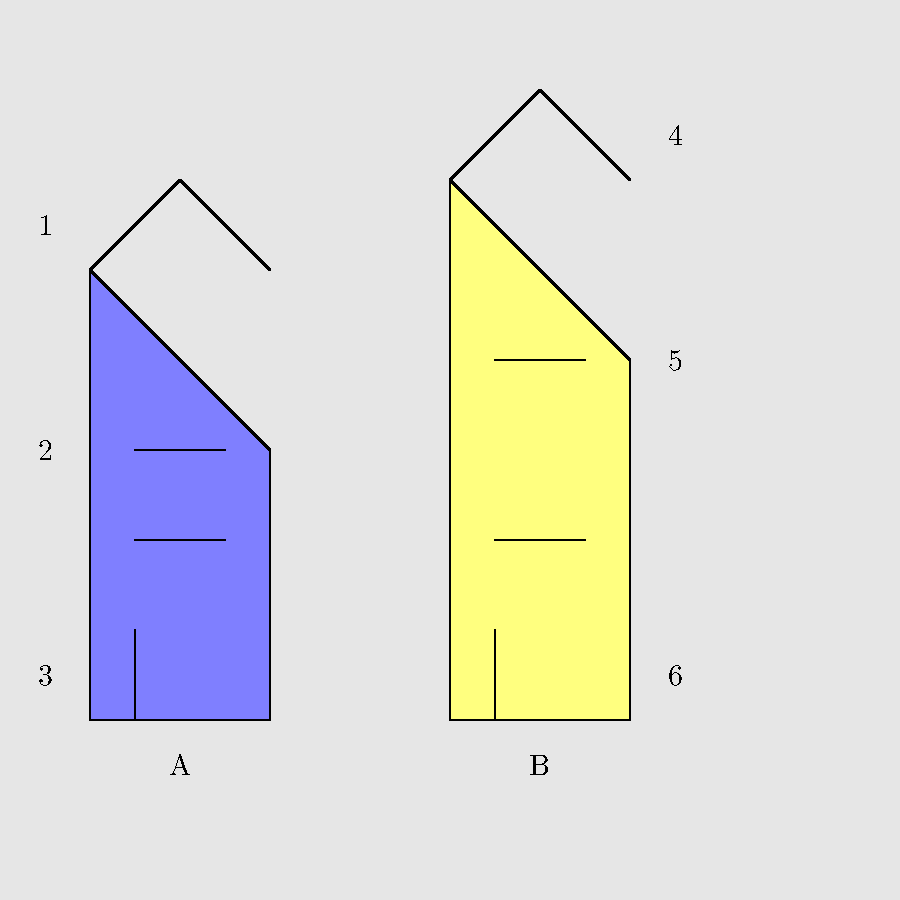Match the traditional Macedonian architectural elements (1-6) to their corresponding buildings (A or B) in this Lesnovo streetscape. To answer this question, we need to analyze the traditional Macedonian architectural elements and match them to the correct buildings:

1. Steep pitched roof: This is a characteristic feature of traditional Macedonian architecture, designed to shed snow and rain. Both houses A and B have steep pitched roofs, but the one labeled '1' corresponds to house A.

2. Small, rectangular windows: These are typical in traditional Macedonian houses for better insulation. The windows labeled '2' are on house A.

3. Wooden door: Traditional Macedonian houses often feature wooden doors. The door labeled '3' is on house A.

4. Triangular roof shape: This is another common feature in Macedonian architecture. The roof labeled '4' corresponds to house B.

5. Larger windows: As building techniques advanced, some houses incorporated larger windows. The windows labeled '5' are on house B.

6. Centered door: Many traditional Macedonian houses have a centered main entrance. The door labeled '6' is on house B.

By matching these elements to their respective buildings, we can determine which architectural features belong to each house in the Lesnovo streetscape.
Answer: 1-A, 2-A, 3-A, 4-B, 5-B, 6-B 